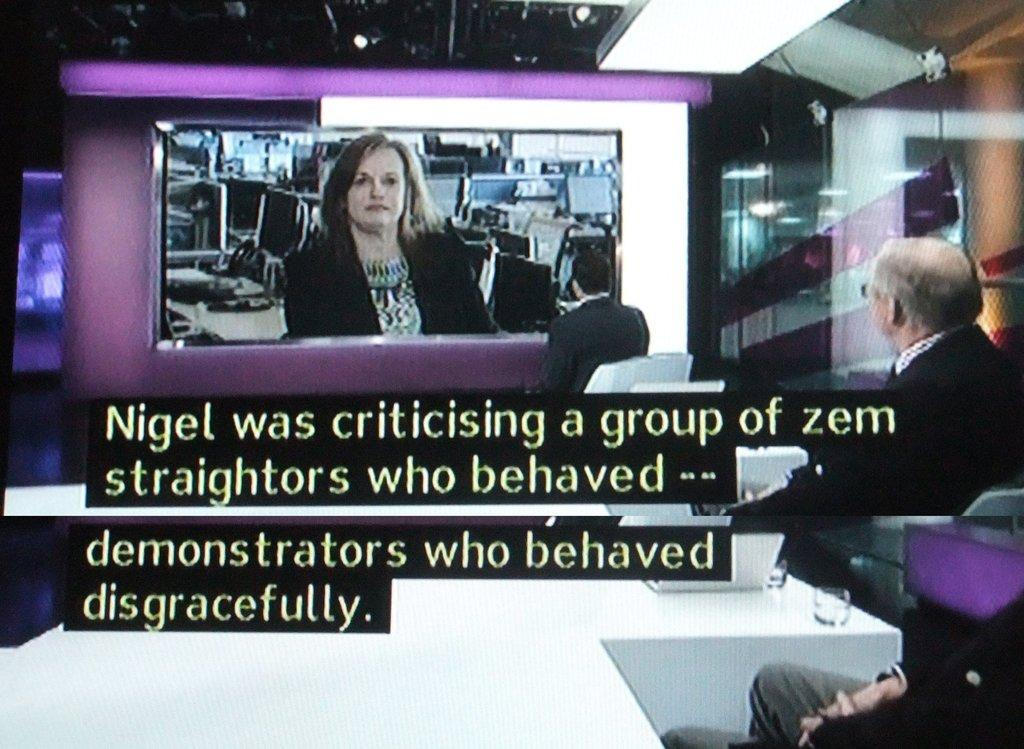<image>
Summarize the visual content of the image. Closed caption news broadcast conversing about demonstrators who behaved disgracefully. 